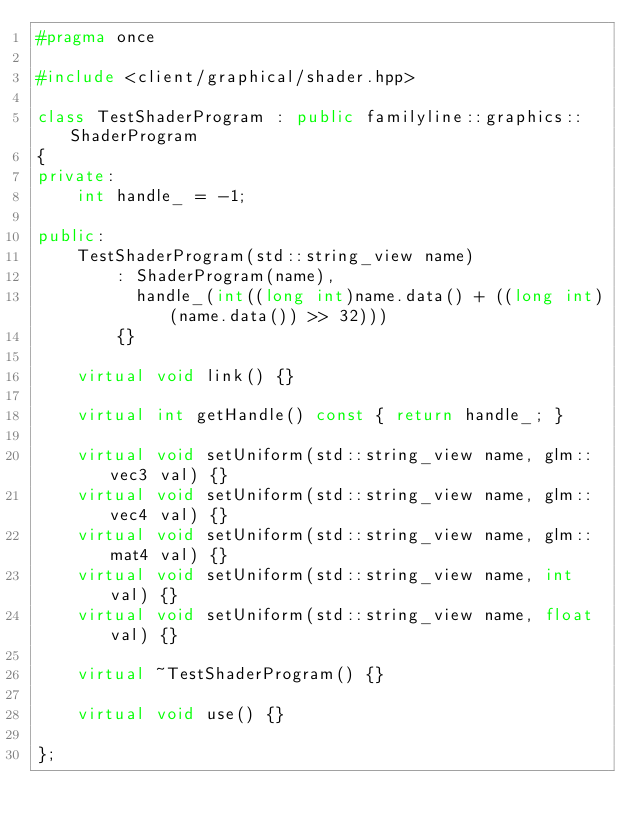Convert code to text. <code><loc_0><loc_0><loc_500><loc_500><_C++_>#pragma once

#include <client/graphical/shader.hpp>

class TestShaderProgram : public familyline::graphics::ShaderProgram
{
private:
    int handle_ = -1;

public:
    TestShaderProgram(std::string_view name)
        : ShaderProgram(name),
          handle_(int((long int)name.data() + ((long int)(name.data()) >> 32)))
        {}

    virtual void link() {}

    virtual int getHandle() const { return handle_; }

    virtual void setUniform(std::string_view name, glm::vec3 val) {}
    virtual void setUniform(std::string_view name, glm::vec4 val) {}
    virtual void setUniform(std::string_view name, glm::mat4 val) {}
    virtual void setUniform(std::string_view name, int val) {}
    virtual void setUniform(std::string_view name, float val) {}

    virtual ~TestShaderProgram() {}

    virtual void use() {}

};
</code> 